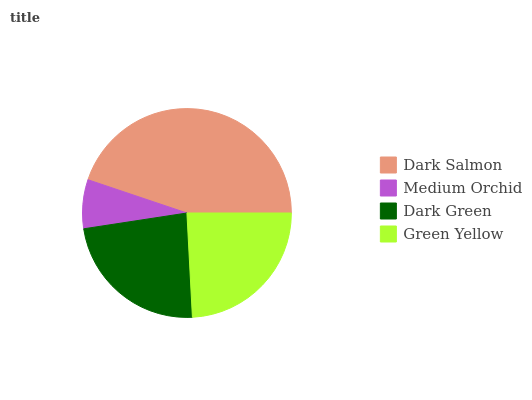Is Medium Orchid the minimum?
Answer yes or no. Yes. Is Dark Salmon the maximum?
Answer yes or no. Yes. Is Dark Green the minimum?
Answer yes or no. No. Is Dark Green the maximum?
Answer yes or no. No. Is Dark Green greater than Medium Orchid?
Answer yes or no. Yes. Is Medium Orchid less than Dark Green?
Answer yes or no. Yes. Is Medium Orchid greater than Dark Green?
Answer yes or no. No. Is Dark Green less than Medium Orchid?
Answer yes or no. No. Is Green Yellow the high median?
Answer yes or no. Yes. Is Dark Green the low median?
Answer yes or no. Yes. Is Dark Green the high median?
Answer yes or no. No. Is Green Yellow the low median?
Answer yes or no. No. 